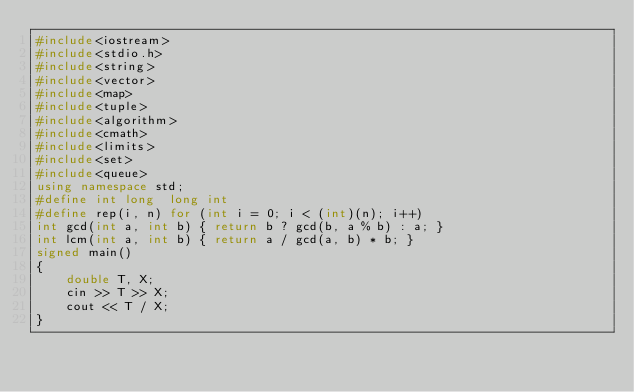Convert code to text. <code><loc_0><loc_0><loc_500><loc_500><_C++_>#include<iostream>
#include<stdio.h>
#include<string>
#include<vector>
#include<map>
#include<tuple>
#include<algorithm>
#include<cmath>
#include<limits>
#include<set>
#include<queue>
using namespace std;
#define int long  long int
#define rep(i, n) for (int i = 0; i < (int)(n); i++)
int gcd(int a, int b) { return b ? gcd(b, a % b) : a; }
int lcm(int a, int b) { return a / gcd(a, b) * b; }
signed main()
{
	double T, X;
	cin >> T >> X;
	cout << T / X;
}</code> 